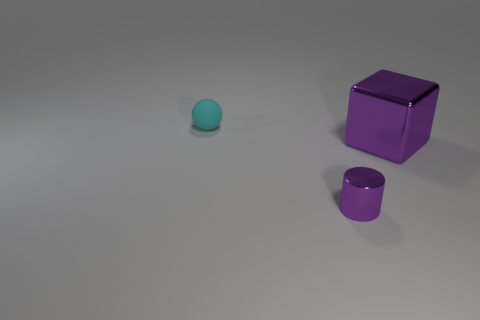Add 2 big purple metal objects. How many objects exist? 5 Add 1 cyan rubber spheres. How many cyan rubber spheres are left? 2 Add 2 yellow shiny blocks. How many yellow shiny blocks exist? 2 Subtract 1 purple cubes. How many objects are left? 2 Subtract all spheres. How many objects are left? 2 Subtract 1 cylinders. How many cylinders are left? 0 Subtract all matte objects. Subtract all tiny brown blocks. How many objects are left? 2 